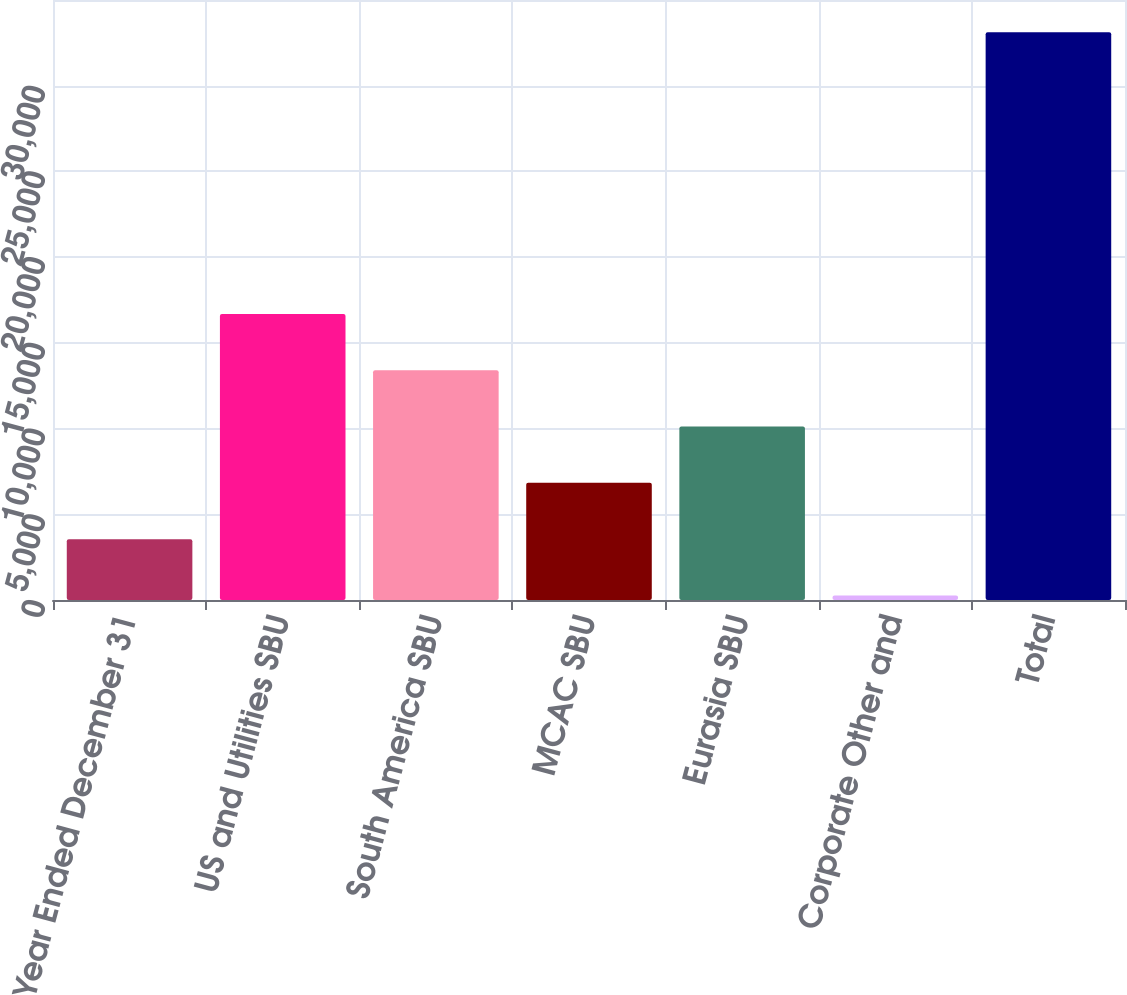<chart> <loc_0><loc_0><loc_500><loc_500><bar_chart><fcel>Year Ended December 31<fcel>US and Utilities SBU<fcel>South America SBU<fcel>MCAC SBU<fcel>Eurasia SBU<fcel>Corporate Other and<fcel>Total<nl><fcel>3547.9<fcel>16687.5<fcel>13402.6<fcel>6832.8<fcel>10117.7<fcel>263<fcel>33112<nl></chart> 